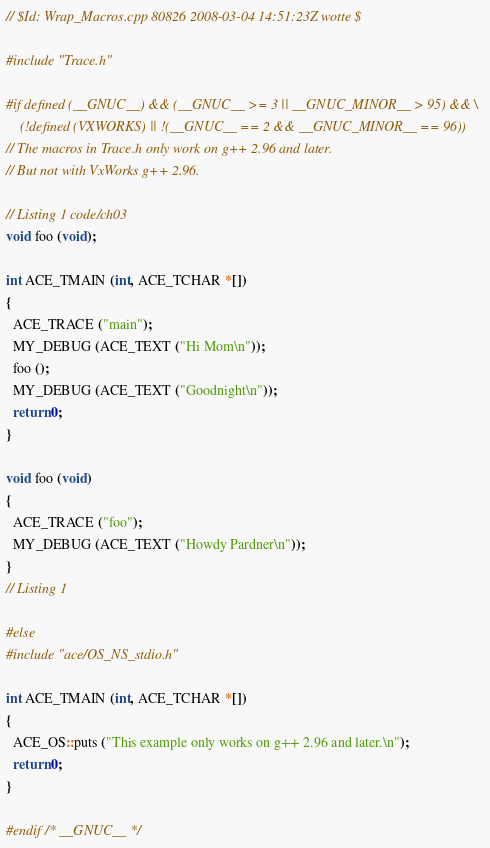<code> <loc_0><loc_0><loc_500><loc_500><_C++_>// $Id: Wrap_Macros.cpp 80826 2008-03-04 14:51:23Z wotte $

#include "Trace.h"

#if defined (__GNUC__) && (__GNUC__ >= 3 || __GNUC_MINOR__ > 95) && \
    (!defined (VXWORKS) || !(__GNUC__ == 2 && __GNUC_MINOR__ == 96))
// The macros in Trace.h only work on g++ 2.96 and later.
// But not with VxWorks g++ 2.96.

// Listing 1 code/ch03
void foo (void);

int ACE_TMAIN (int, ACE_TCHAR *[])
{
  ACE_TRACE ("main");
  MY_DEBUG (ACE_TEXT ("Hi Mom\n"));
  foo ();
  MY_DEBUG (ACE_TEXT ("Goodnight\n"));
  return 0;
}

void foo (void)
{
  ACE_TRACE ("foo");
  MY_DEBUG (ACE_TEXT ("Howdy Pardner\n"));
}
// Listing 1

#else
#include "ace/OS_NS_stdio.h"

int ACE_TMAIN (int, ACE_TCHAR *[])
{
  ACE_OS::puts ("This example only works on g++ 2.96 and later.\n");
  return 0;
}

#endif /* __GNUC__ */
</code> 